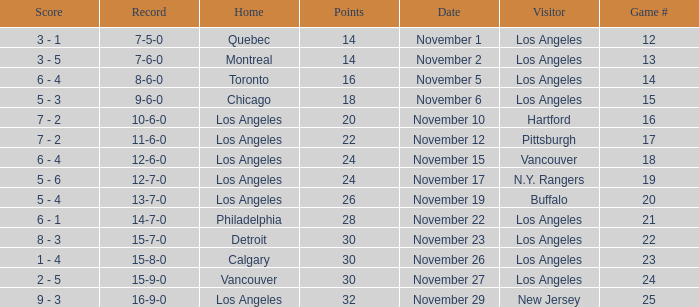What is the record of the game on November 22? 14-7-0. 